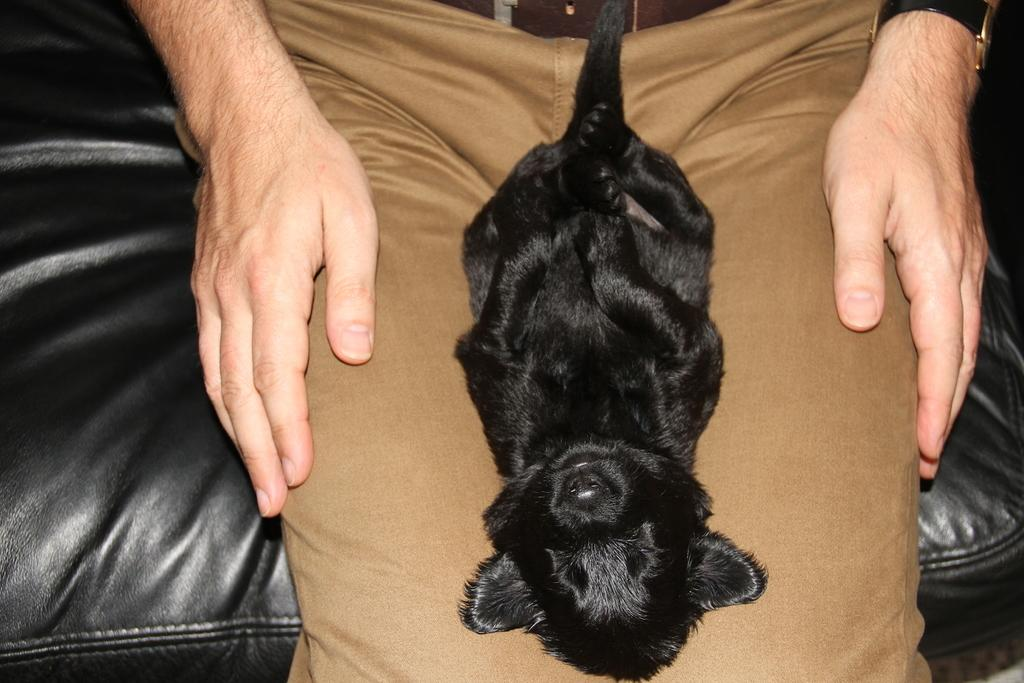What type of animal is in the image? There is an animal in the image, but its specific type is not mentioned in the facts. What color is the animal in the image? The animal is black in color. Where is the animal located in the image? The animal is on the lap of a person. What color are the pants worn by the person in the image? The person is wearing brown-colored pants. What color is the couch that the person is sitting on? The person is sitting on a black-colored couch. Where is the key located in the image? There is no mention of a key in the provided facts, so it cannot be determined where it might be located in the image. 